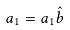<formula> <loc_0><loc_0><loc_500><loc_500>a _ { 1 } = a _ { 1 } \hat { b }</formula> 